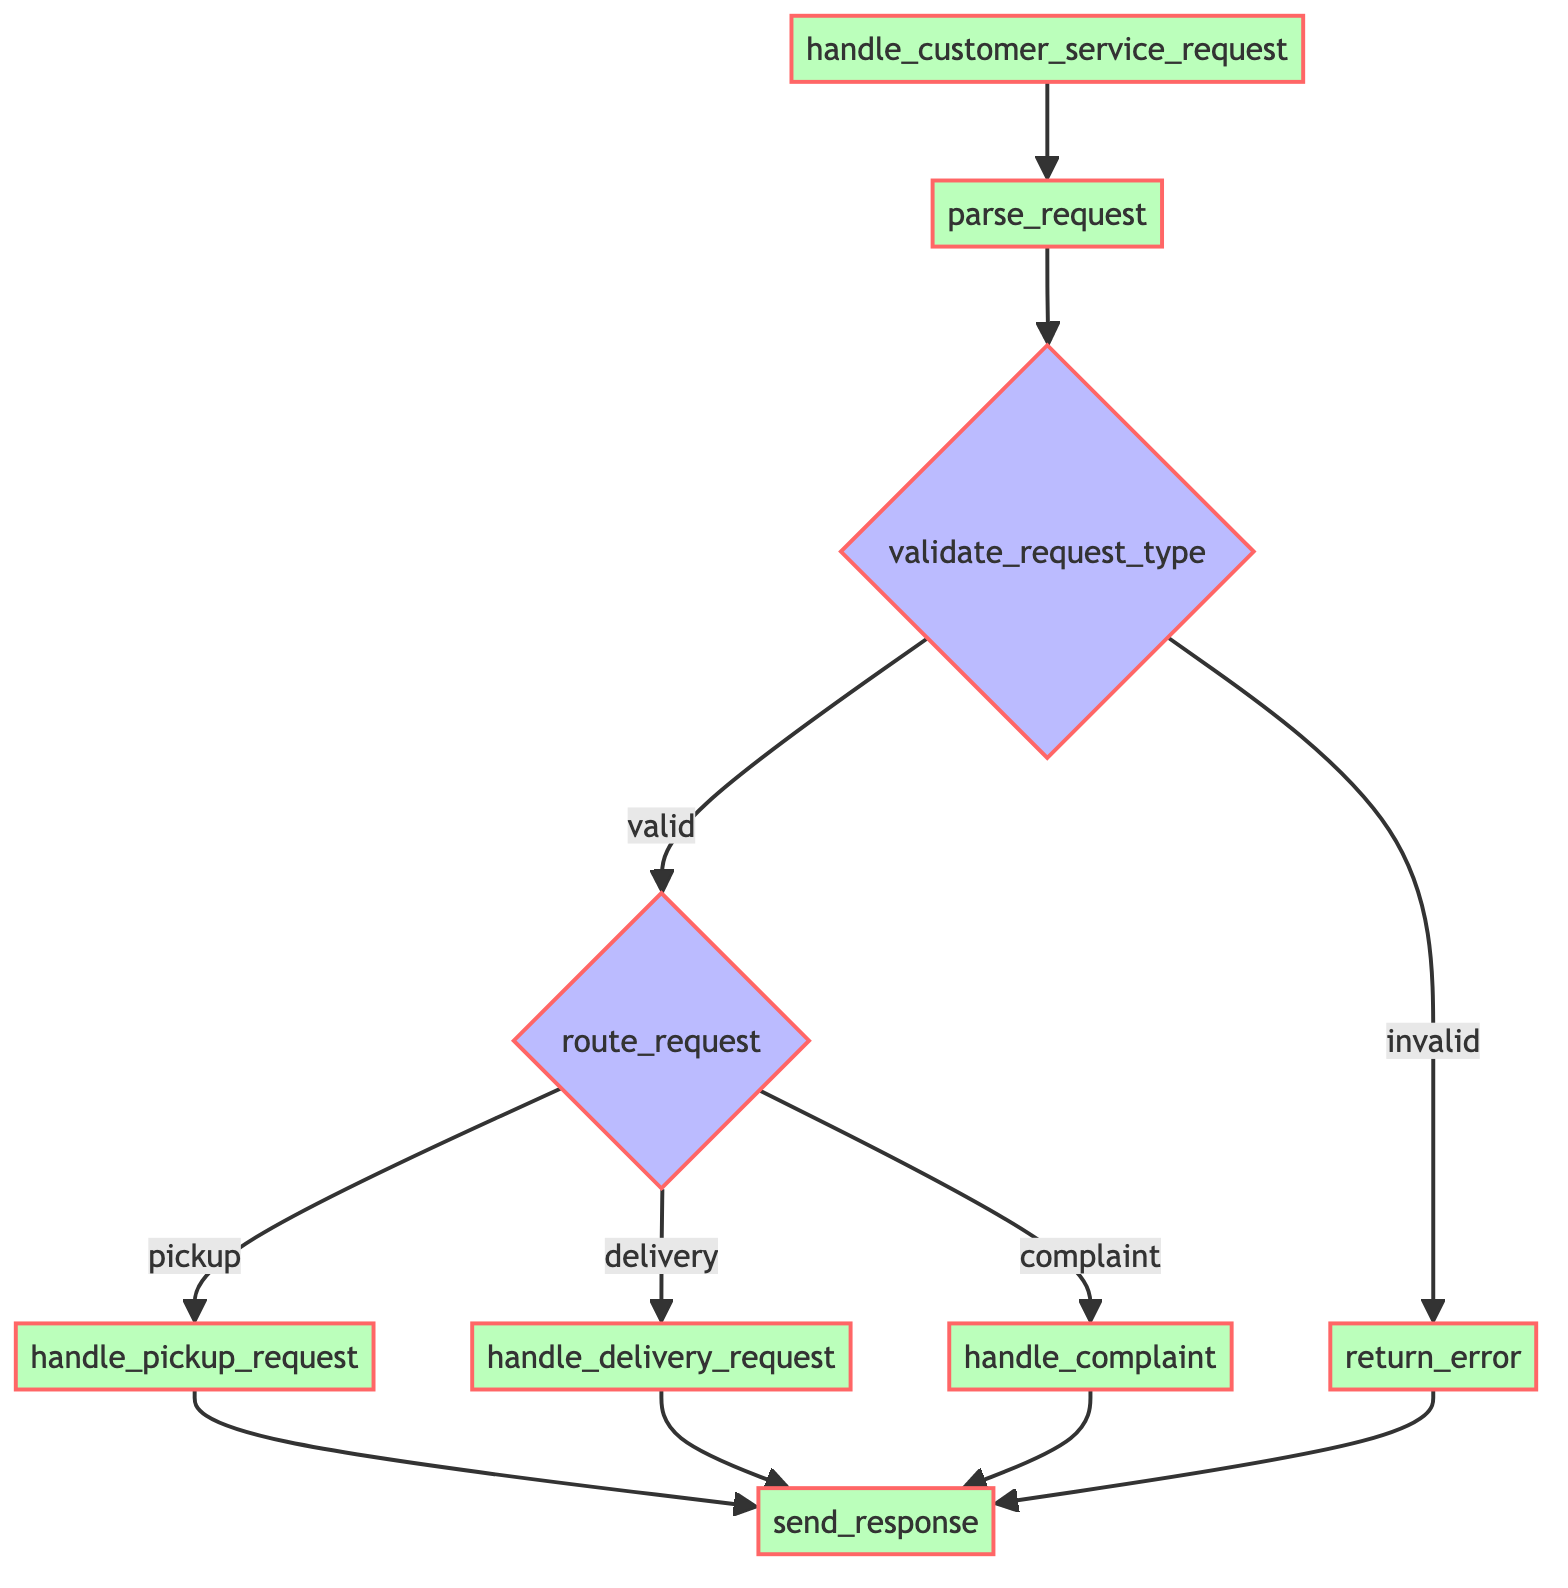What is the first function called in the diagram? The flowchart starts with the function named "handle_customer_service_request," which initiates the process of handling customer service requests.
Answer: handle_customer_service_request How many decision nodes are present in the diagram? There are three decision nodes in the diagram: "validate_request_type," "route_request," and the two branches of "route_request" based on request types.
Answer: 3 If the request type is "invalid," what is the next function called? If the request type is identified as "invalid" at the "validate_request_type" decision node, the next function called is "return_error," which provides an error message to the customer.
Answer: return_error What condition leads to the "handle_pickup_request" function? The "handle_pickup_request" function is reached when the "route_request" decision node forwards the flow for a "pickup" condition after the request type has been validated.
Answer: pickup What is the final function that sends a response to the customer? All paths lead to the final function called "send_response," which sends a confirmation or resolution details back to the customer regardless of the request type or outcome of previous functions.
Answer: send_response What happens after the "parse_request" function? After the "parse_request" function is executed, the flow moves to the decision node "validate_request_type," where the request type is validated as either valid or invalid.
Answer: validate_request_type How does the flow proceed if the request type is valid? If the request type is valid, the flow proceeds to the "route_request" decision node, where further routing decisions are made based on the specific type of request (pickup, delivery, complaint).
Answer: route_request What does the "handle_complaint" function do? The "handle_complaint" function processes customer complaints, addressing them accordingly based on the nature of the complaint received.
Answer: Address complaints How many edges connect the "validate_request_type" node to other nodes? The "validate_request_type" node has two outgoing edges connecting to other nodes: one to "route_request" for a valid request and one to "return_error" for an invalid request.
Answer: 2 